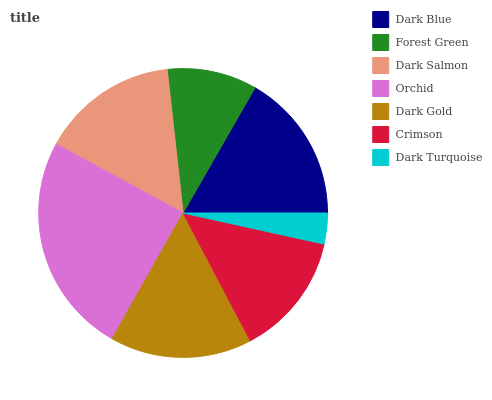Is Dark Turquoise the minimum?
Answer yes or no. Yes. Is Orchid the maximum?
Answer yes or no. Yes. Is Forest Green the minimum?
Answer yes or no. No. Is Forest Green the maximum?
Answer yes or no. No. Is Dark Blue greater than Forest Green?
Answer yes or no. Yes. Is Forest Green less than Dark Blue?
Answer yes or no. Yes. Is Forest Green greater than Dark Blue?
Answer yes or no. No. Is Dark Blue less than Forest Green?
Answer yes or no. No. Is Dark Salmon the high median?
Answer yes or no. Yes. Is Dark Salmon the low median?
Answer yes or no. Yes. Is Dark Gold the high median?
Answer yes or no. No. Is Dark Blue the low median?
Answer yes or no. No. 